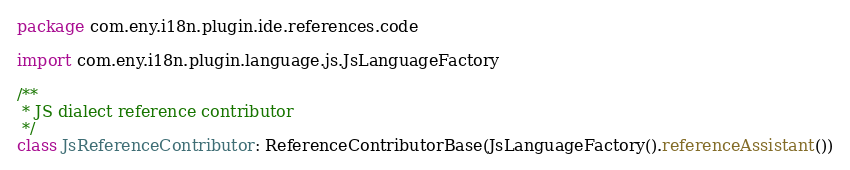Convert code to text. <code><loc_0><loc_0><loc_500><loc_500><_Kotlin_>package com.eny.i18n.plugin.ide.references.code

import com.eny.i18n.plugin.language.js.JsLanguageFactory

/**
 * JS dialect reference contributor
 */
class JsReferenceContributor: ReferenceContributorBase(JsLanguageFactory().referenceAssistant())</code> 